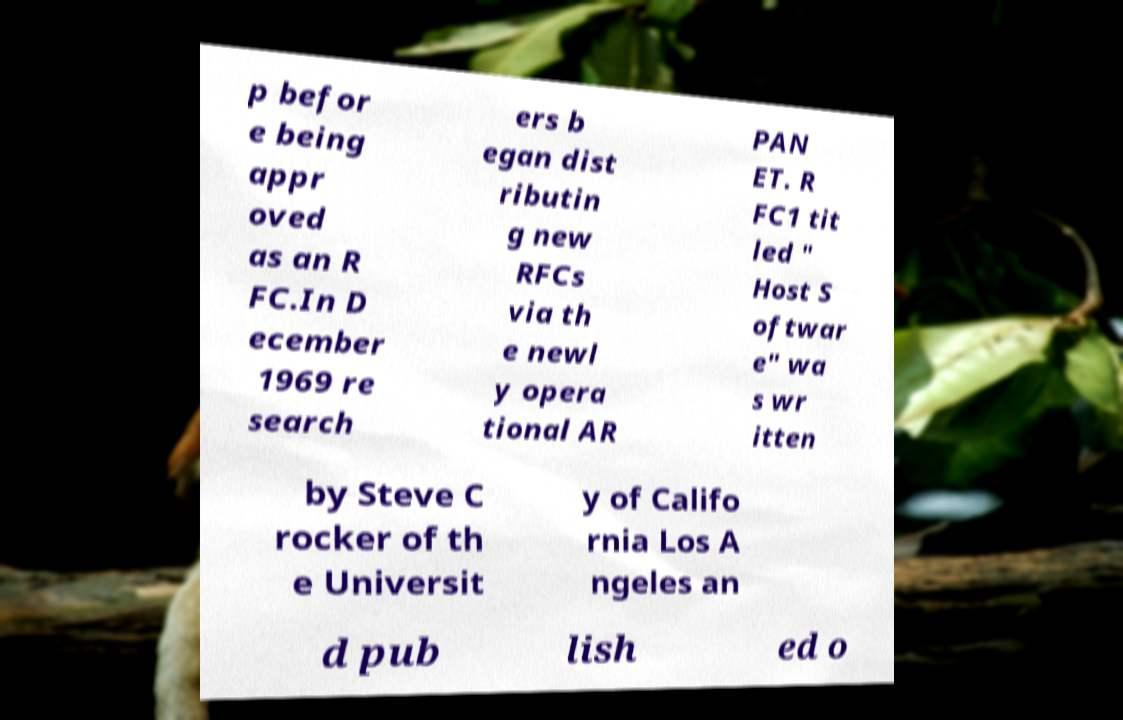Could you extract and type out the text from this image? p befor e being appr oved as an R FC.In D ecember 1969 re search ers b egan dist ributin g new RFCs via th e newl y opera tional AR PAN ET. R FC1 tit led " Host S oftwar e" wa s wr itten by Steve C rocker of th e Universit y of Califo rnia Los A ngeles an d pub lish ed o 